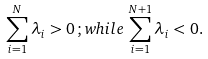Convert formula to latex. <formula><loc_0><loc_0><loc_500><loc_500>\sum _ { i = 1 } ^ { N } \lambda _ { i } > 0 \, ; w h i l e \, \sum _ { i = 1 } ^ { N + 1 } \lambda _ { i } < 0 .</formula> 